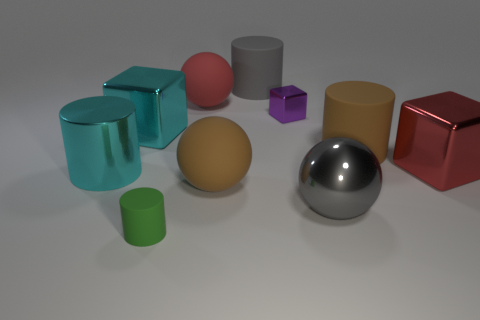Subtract all gray cylinders. How many cylinders are left? 3 Subtract 1 cylinders. How many cylinders are left? 3 Subtract all blue cylinders. Subtract all blue blocks. How many cylinders are left? 4 Subtract all blocks. How many objects are left? 7 Add 2 cylinders. How many cylinders are left? 6 Add 5 large cyan rubber spheres. How many large cyan rubber spheres exist? 5 Subtract 1 brown cylinders. How many objects are left? 9 Subtract all red cubes. Subtract all shiny objects. How many objects are left? 4 